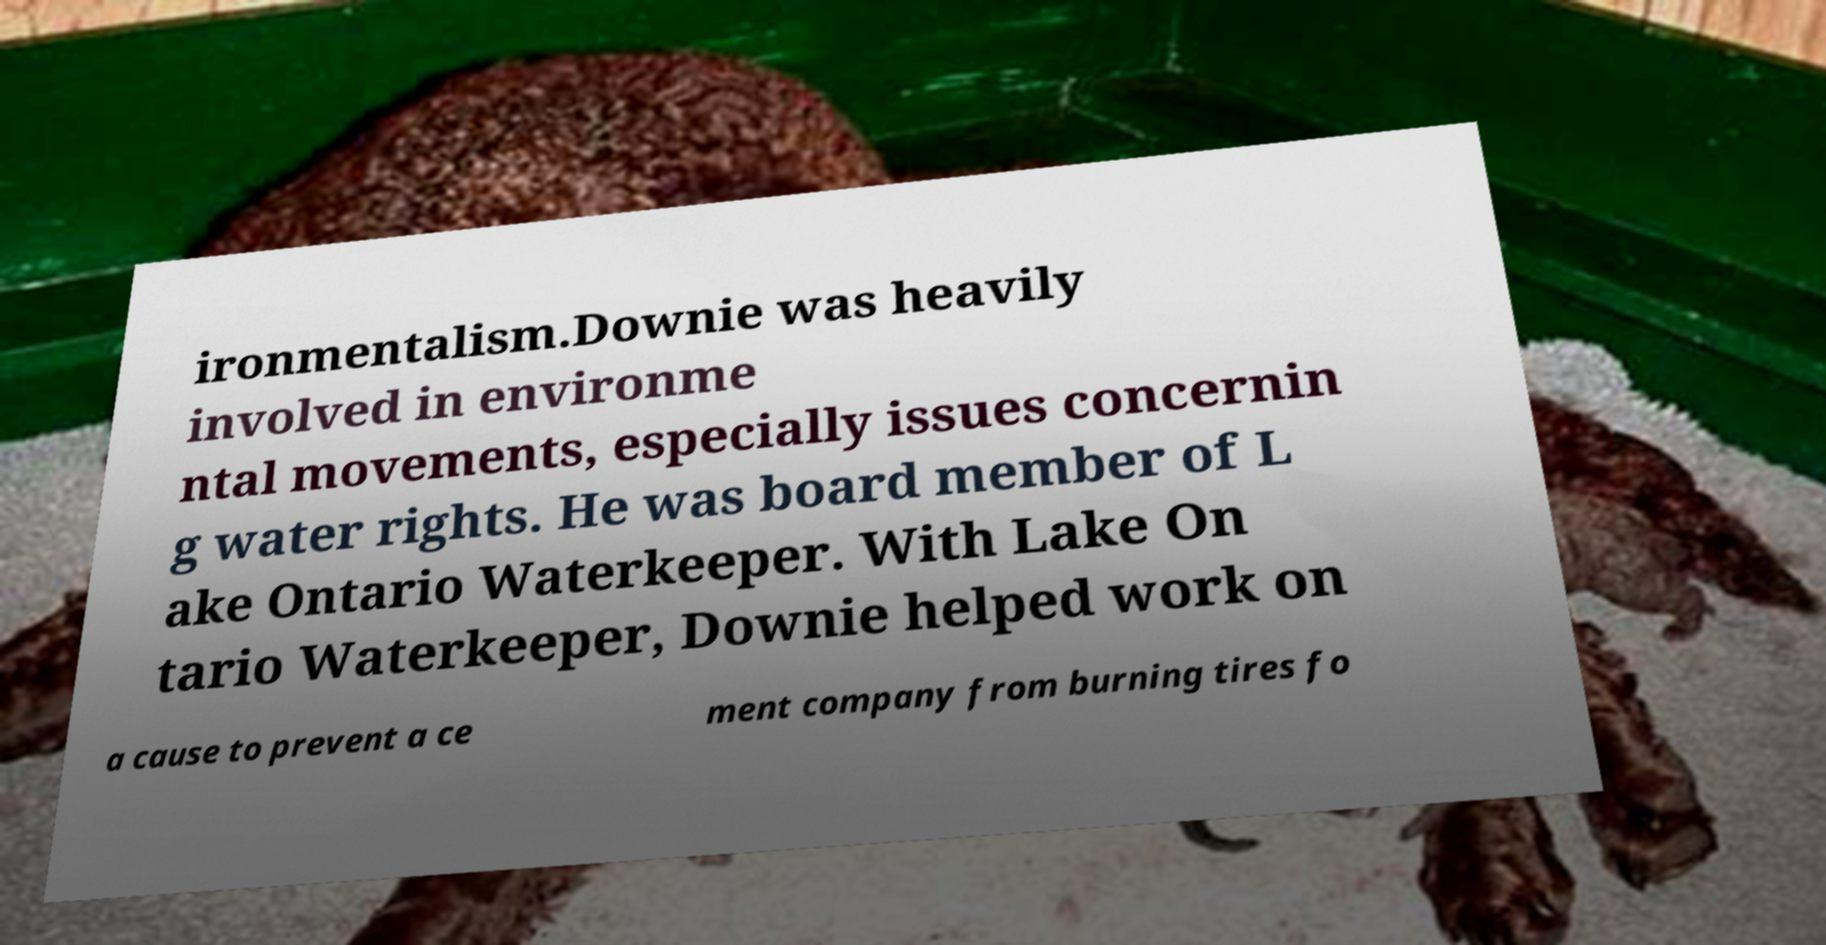Please read and relay the text visible in this image. What does it say? ironmentalism.Downie was heavily involved in environme ntal movements, especially issues concernin g water rights. He was board member of L ake Ontario Waterkeeper. With Lake On tario Waterkeeper, Downie helped work on a cause to prevent a ce ment company from burning tires fo 